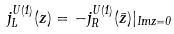Convert formula to latex. <formula><loc_0><loc_0><loc_500><loc_500>j _ { L } ^ { U ( 1 ) } ( z ) = - j _ { R } ^ { U ( 1 ) } ( { \bar { z } } ) | _ { I m z = 0 }</formula> 